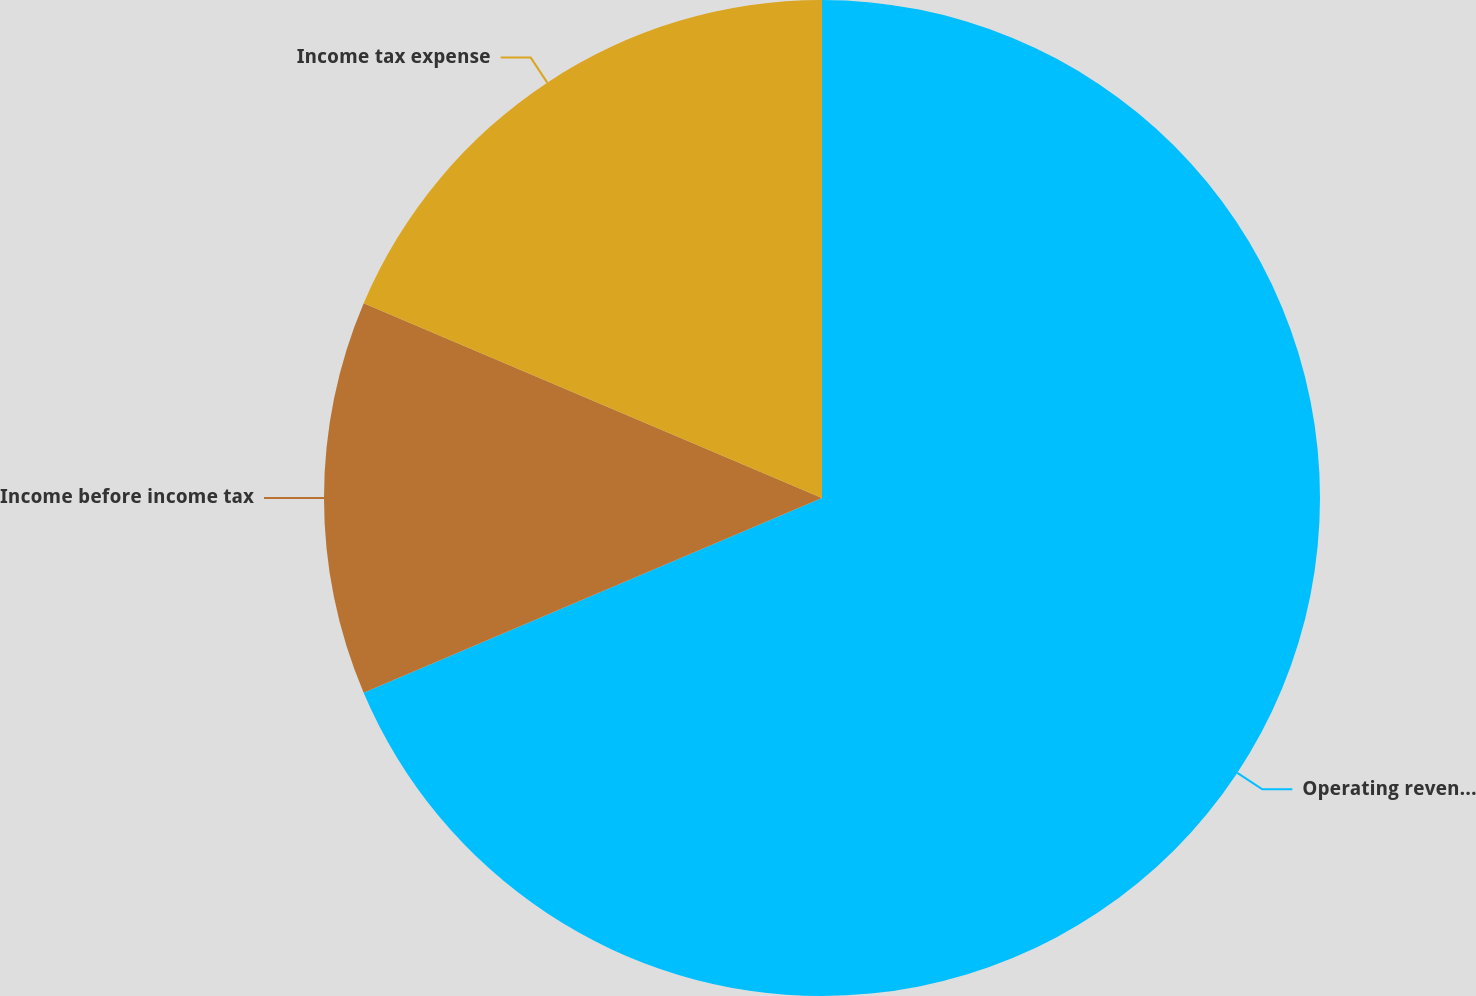<chart> <loc_0><loc_0><loc_500><loc_500><pie_chart><fcel>Operating revenues<fcel>Income before income tax<fcel>Income tax expense<nl><fcel>68.6%<fcel>12.79%<fcel>18.6%<nl></chart> 